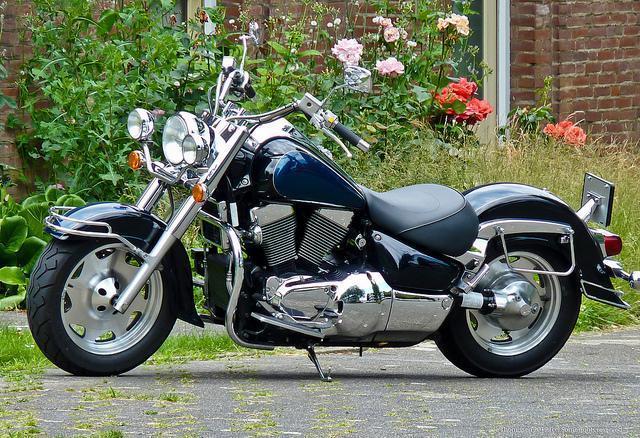How many motorcycles are there?
Give a very brief answer. 1. How many people in the image are wearing bright green jackets?
Give a very brief answer. 0. 